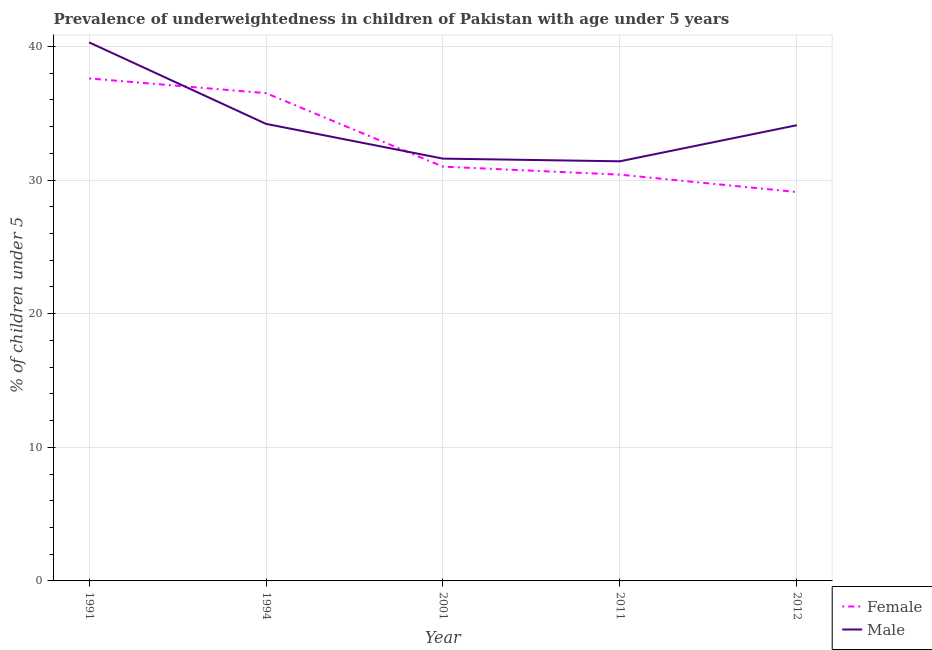How many different coloured lines are there?
Provide a short and direct response. 2. Does the line corresponding to percentage of underweighted female children intersect with the line corresponding to percentage of underweighted male children?
Provide a succinct answer. Yes. Is the number of lines equal to the number of legend labels?
Your answer should be very brief. Yes. What is the percentage of underweighted female children in 2012?
Provide a succinct answer. 29.1. Across all years, what is the maximum percentage of underweighted female children?
Offer a very short reply. 37.6. Across all years, what is the minimum percentage of underweighted female children?
Offer a terse response. 29.1. In which year was the percentage of underweighted male children maximum?
Give a very brief answer. 1991. In which year was the percentage of underweighted female children minimum?
Your answer should be compact. 2012. What is the total percentage of underweighted female children in the graph?
Your answer should be compact. 164.6. What is the difference between the percentage of underweighted female children in 1991 and that in 2001?
Provide a succinct answer. 6.6. What is the difference between the percentage of underweighted male children in 1991 and the percentage of underweighted female children in 2011?
Keep it short and to the point. 9.9. What is the average percentage of underweighted male children per year?
Give a very brief answer. 34.32. In the year 1994, what is the difference between the percentage of underweighted female children and percentage of underweighted male children?
Give a very brief answer. 2.3. What is the ratio of the percentage of underweighted male children in 1991 to that in 1994?
Provide a short and direct response. 1.18. What is the difference between the highest and the second highest percentage of underweighted male children?
Give a very brief answer. 6.1. What is the difference between the highest and the lowest percentage of underweighted male children?
Make the answer very short. 8.9. Does the percentage of underweighted female children monotonically increase over the years?
Give a very brief answer. No. Is the percentage of underweighted female children strictly greater than the percentage of underweighted male children over the years?
Provide a succinct answer. No. How many lines are there?
Provide a succinct answer. 2. How many years are there in the graph?
Your answer should be very brief. 5. Are the values on the major ticks of Y-axis written in scientific E-notation?
Your answer should be very brief. No. Does the graph contain any zero values?
Your answer should be very brief. No. Does the graph contain grids?
Provide a succinct answer. Yes. What is the title of the graph?
Offer a terse response. Prevalence of underweightedness in children of Pakistan with age under 5 years. What is the label or title of the X-axis?
Offer a very short reply. Year. What is the label or title of the Y-axis?
Your answer should be very brief.  % of children under 5. What is the  % of children under 5 in Female in 1991?
Make the answer very short. 37.6. What is the  % of children under 5 of Male in 1991?
Provide a succinct answer. 40.3. What is the  % of children under 5 in Female in 1994?
Make the answer very short. 36.5. What is the  % of children under 5 in Male in 1994?
Offer a very short reply. 34.2. What is the  % of children under 5 of Male in 2001?
Your response must be concise. 31.6. What is the  % of children under 5 of Female in 2011?
Your answer should be very brief. 30.4. What is the  % of children under 5 in Male in 2011?
Make the answer very short. 31.4. What is the  % of children under 5 in Female in 2012?
Ensure brevity in your answer.  29.1. What is the  % of children under 5 in Male in 2012?
Provide a succinct answer. 34.1. Across all years, what is the maximum  % of children under 5 in Female?
Offer a very short reply. 37.6. Across all years, what is the maximum  % of children under 5 in Male?
Your response must be concise. 40.3. Across all years, what is the minimum  % of children under 5 in Female?
Provide a succinct answer. 29.1. Across all years, what is the minimum  % of children under 5 of Male?
Your answer should be very brief. 31.4. What is the total  % of children under 5 in Female in the graph?
Your answer should be compact. 164.6. What is the total  % of children under 5 in Male in the graph?
Offer a terse response. 171.6. What is the difference between the  % of children under 5 in Female in 1991 and that in 1994?
Make the answer very short. 1.1. What is the difference between the  % of children under 5 of Female in 1991 and that in 2001?
Give a very brief answer. 6.6. What is the difference between the  % of children under 5 of Male in 1991 and that in 2001?
Ensure brevity in your answer.  8.7. What is the difference between the  % of children under 5 of Female in 1991 and that in 2012?
Offer a terse response. 8.5. What is the difference between the  % of children under 5 in Male in 1991 and that in 2012?
Offer a terse response. 6.2. What is the difference between the  % of children under 5 in Female in 1994 and that in 2001?
Your answer should be very brief. 5.5. What is the difference between the  % of children under 5 of Male in 1994 and that in 2001?
Ensure brevity in your answer.  2.6. What is the difference between the  % of children under 5 of Female in 1994 and that in 2012?
Your answer should be very brief. 7.4. What is the difference between the  % of children under 5 of Female in 2001 and that in 2011?
Provide a short and direct response. 0.6. What is the difference between the  % of children under 5 of Female in 2011 and that in 2012?
Ensure brevity in your answer.  1.3. What is the difference between the  % of children under 5 of Female in 1991 and the  % of children under 5 of Male in 1994?
Keep it short and to the point. 3.4. What is the difference between the  % of children under 5 in Female in 1991 and the  % of children under 5 in Male in 2011?
Your response must be concise. 6.2. What is the difference between the  % of children under 5 of Female in 1994 and the  % of children under 5 of Male in 2001?
Your answer should be very brief. 4.9. What is the difference between the  % of children under 5 in Female in 1994 and the  % of children under 5 in Male in 2011?
Your answer should be compact. 5.1. What is the difference between the  % of children under 5 of Female in 2001 and the  % of children under 5 of Male in 2011?
Make the answer very short. -0.4. What is the difference between the  % of children under 5 of Female in 2011 and the  % of children under 5 of Male in 2012?
Keep it short and to the point. -3.7. What is the average  % of children under 5 of Female per year?
Your answer should be compact. 32.92. What is the average  % of children under 5 of Male per year?
Provide a succinct answer. 34.32. What is the ratio of the  % of children under 5 in Female in 1991 to that in 1994?
Provide a succinct answer. 1.03. What is the ratio of the  % of children under 5 of Male in 1991 to that in 1994?
Offer a very short reply. 1.18. What is the ratio of the  % of children under 5 of Female in 1991 to that in 2001?
Provide a short and direct response. 1.21. What is the ratio of the  % of children under 5 of Male in 1991 to that in 2001?
Offer a terse response. 1.28. What is the ratio of the  % of children under 5 in Female in 1991 to that in 2011?
Offer a terse response. 1.24. What is the ratio of the  % of children under 5 of Male in 1991 to that in 2011?
Provide a succinct answer. 1.28. What is the ratio of the  % of children under 5 of Female in 1991 to that in 2012?
Offer a terse response. 1.29. What is the ratio of the  % of children under 5 of Male in 1991 to that in 2012?
Your answer should be compact. 1.18. What is the ratio of the  % of children under 5 in Female in 1994 to that in 2001?
Keep it short and to the point. 1.18. What is the ratio of the  % of children under 5 in Male in 1994 to that in 2001?
Provide a succinct answer. 1.08. What is the ratio of the  % of children under 5 of Female in 1994 to that in 2011?
Give a very brief answer. 1.2. What is the ratio of the  % of children under 5 in Male in 1994 to that in 2011?
Keep it short and to the point. 1.09. What is the ratio of the  % of children under 5 in Female in 1994 to that in 2012?
Offer a very short reply. 1.25. What is the ratio of the  % of children under 5 of Female in 2001 to that in 2011?
Provide a short and direct response. 1.02. What is the ratio of the  % of children under 5 of Male in 2001 to that in 2011?
Your answer should be compact. 1.01. What is the ratio of the  % of children under 5 of Female in 2001 to that in 2012?
Your response must be concise. 1.07. What is the ratio of the  % of children under 5 in Male in 2001 to that in 2012?
Provide a short and direct response. 0.93. What is the ratio of the  % of children under 5 of Female in 2011 to that in 2012?
Your response must be concise. 1.04. What is the ratio of the  % of children under 5 of Male in 2011 to that in 2012?
Offer a very short reply. 0.92. What is the difference between the highest and the second highest  % of children under 5 in Female?
Offer a terse response. 1.1. What is the difference between the highest and the lowest  % of children under 5 of Female?
Your answer should be very brief. 8.5. 